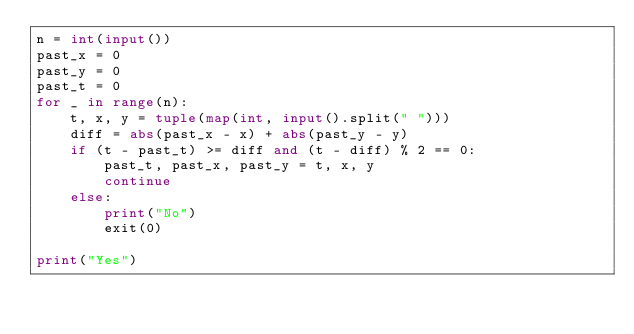Convert code to text. <code><loc_0><loc_0><loc_500><loc_500><_Python_>n = int(input())
past_x = 0
past_y = 0
past_t = 0
for _ in range(n):
    t, x, y = tuple(map(int, input().split(" ")))
    diff = abs(past_x - x) + abs(past_y - y)
    if (t - past_t) >= diff and (t - diff) % 2 == 0:
        past_t, past_x, past_y = t, x, y
        continue
    else:
        print("No")
        exit(0)

print("Yes")</code> 